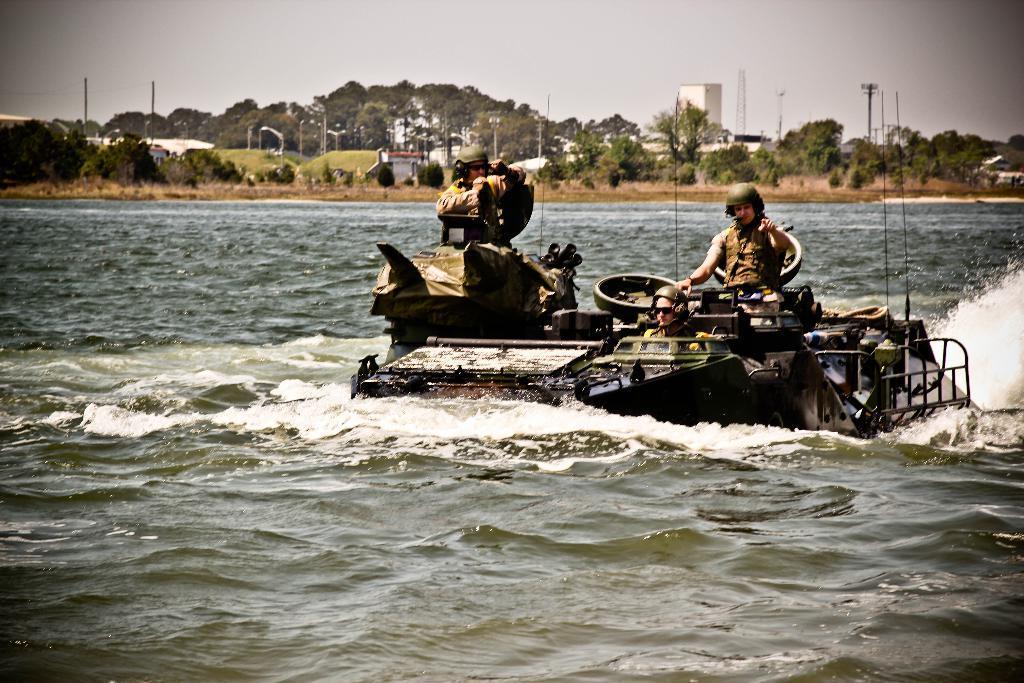How would you summarize this image in a sentence or two? In this picture I can observe an armored vehicle in the water. There are some soldiers in this vehicle. In the background there are trees and sky. 